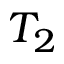Convert formula to latex. <formula><loc_0><loc_0><loc_500><loc_500>T _ { 2 }</formula> 